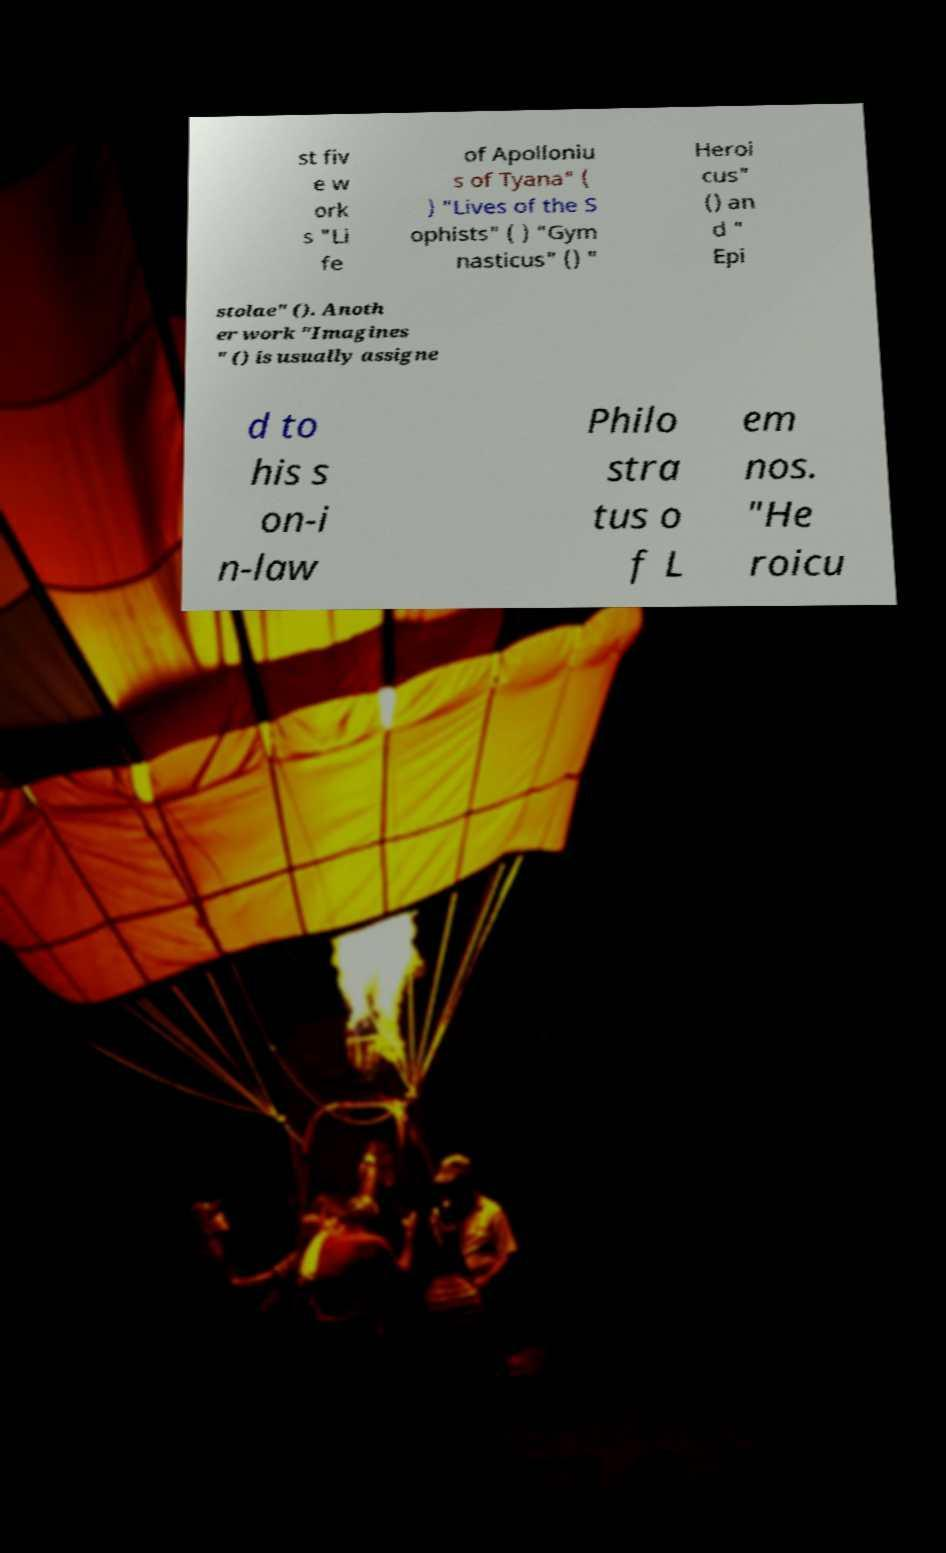Please read and relay the text visible in this image. What does it say? st fiv e w ork s "Li fe of Apolloniu s of Tyana" ( ) "Lives of the S ophists" ( ) "Gym nasticus" () " Heroi cus" () an d " Epi stolae" (). Anoth er work "Imagines " () is usually assigne d to his s on-i n-law Philo stra tus o f L em nos. "He roicu 